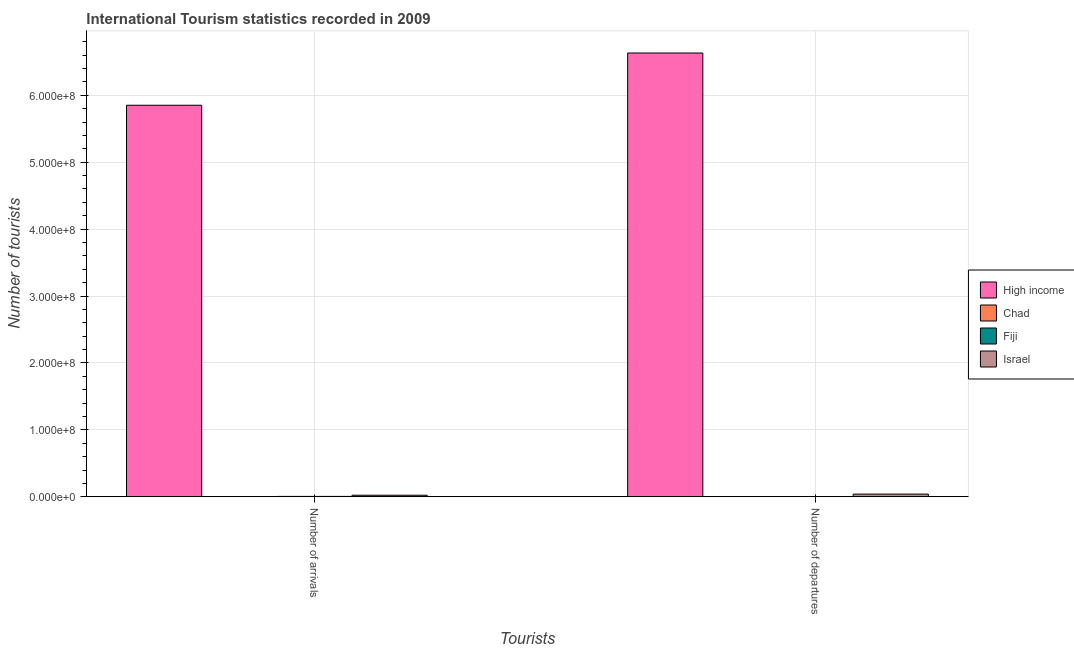How many different coloured bars are there?
Make the answer very short. 4. Are the number of bars per tick equal to the number of legend labels?
Keep it short and to the point. Yes. Are the number of bars on each tick of the X-axis equal?
Ensure brevity in your answer.  Yes. How many bars are there on the 2nd tick from the left?
Your answer should be compact. 4. How many bars are there on the 2nd tick from the right?
Give a very brief answer. 4. What is the label of the 1st group of bars from the left?
Provide a succinct answer. Number of arrivals. What is the number of tourist arrivals in Chad?
Provide a short and direct response. 7.00e+04. Across all countries, what is the maximum number of tourist departures?
Keep it short and to the point. 6.63e+08. In which country was the number of tourist departures minimum?
Make the answer very short. Chad. What is the total number of tourist arrivals in the graph?
Make the answer very short. 5.88e+08. What is the difference between the number of tourist departures in High income and that in Chad?
Your answer should be very brief. 6.63e+08. What is the difference between the number of tourist arrivals in Chad and the number of tourist departures in Fiji?
Ensure brevity in your answer.  -5.50e+04. What is the average number of tourist departures per country?
Offer a very short reply. 1.67e+08. What is the difference between the number of tourist arrivals and number of tourist departures in Chad?
Make the answer very short. 4000. What is the ratio of the number of tourist arrivals in High income to that in Fiji?
Offer a very short reply. 1079.57. What does the 2nd bar from the left in Number of departures represents?
Make the answer very short. Chad. What does the 3rd bar from the right in Number of departures represents?
Keep it short and to the point. Chad. How many bars are there?
Ensure brevity in your answer.  8. Are all the bars in the graph horizontal?
Ensure brevity in your answer.  No. How many countries are there in the graph?
Keep it short and to the point. 4. Are the values on the major ticks of Y-axis written in scientific E-notation?
Provide a succinct answer. Yes. Does the graph contain grids?
Offer a terse response. Yes. How many legend labels are there?
Keep it short and to the point. 4. What is the title of the graph?
Your answer should be very brief. International Tourism statistics recorded in 2009. What is the label or title of the X-axis?
Ensure brevity in your answer.  Tourists. What is the label or title of the Y-axis?
Your answer should be very brief. Number of tourists. What is the Number of tourists of High income in Number of arrivals?
Give a very brief answer. 5.85e+08. What is the Number of tourists of Fiji in Number of arrivals?
Offer a terse response. 5.42e+05. What is the Number of tourists in Israel in Number of arrivals?
Offer a terse response. 2.32e+06. What is the Number of tourists in High income in Number of departures?
Ensure brevity in your answer.  6.63e+08. What is the Number of tourists in Chad in Number of departures?
Offer a very short reply. 6.60e+04. What is the Number of tourists of Fiji in Number of departures?
Give a very brief answer. 1.25e+05. What is the Number of tourists in Israel in Number of departures?
Make the answer very short. 4.01e+06. Across all Tourists, what is the maximum Number of tourists in High income?
Give a very brief answer. 6.63e+08. Across all Tourists, what is the maximum Number of tourists in Fiji?
Ensure brevity in your answer.  5.42e+05. Across all Tourists, what is the maximum Number of tourists in Israel?
Provide a short and direct response. 4.01e+06. Across all Tourists, what is the minimum Number of tourists of High income?
Provide a short and direct response. 5.85e+08. Across all Tourists, what is the minimum Number of tourists of Chad?
Offer a terse response. 6.60e+04. Across all Tourists, what is the minimum Number of tourists of Fiji?
Make the answer very short. 1.25e+05. Across all Tourists, what is the minimum Number of tourists in Israel?
Offer a terse response. 2.32e+06. What is the total Number of tourists of High income in the graph?
Your answer should be compact. 1.25e+09. What is the total Number of tourists of Chad in the graph?
Offer a very short reply. 1.36e+05. What is the total Number of tourists in Fiji in the graph?
Offer a terse response. 6.67e+05. What is the total Number of tourists of Israel in the graph?
Provide a short and direct response. 6.33e+06. What is the difference between the Number of tourists in High income in Number of arrivals and that in Number of departures?
Provide a succinct answer. -7.80e+07. What is the difference between the Number of tourists in Chad in Number of arrivals and that in Number of departures?
Give a very brief answer. 4000. What is the difference between the Number of tourists in Fiji in Number of arrivals and that in Number of departures?
Your answer should be very brief. 4.17e+05. What is the difference between the Number of tourists in Israel in Number of arrivals and that in Number of departures?
Provide a succinct answer. -1.69e+06. What is the difference between the Number of tourists in High income in Number of arrivals and the Number of tourists in Chad in Number of departures?
Ensure brevity in your answer.  5.85e+08. What is the difference between the Number of tourists of High income in Number of arrivals and the Number of tourists of Fiji in Number of departures?
Ensure brevity in your answer.  5.85e+08. What is the difference between the Number of tourists of High income in Number of arrivals and the Number of tourists of Israel in Number of departures?
Your answer should be compact. 5.81e+08. What is the difference between the Number of tourists of Chad in Number of arrivals and the Number of tourists of Fiji in Number of departures?
Offer a terse response. -5.50e+04. What is the difference between the Number of tourists in Chad in Number of arrivals and the Number of tourists in Israel in Number of departures?
Your answer should be very brief. -3.94e+06. What is the difference between the Number of tourists in Fiji in Number of arrivals and the Number of tourists in Israel in Number of departures?
Give a very brief answer. -3.46e+06. What is the average Number of tourists of High income per Tourists?
Offer a terse response. 6.24e+08. What is the average Number of tourists of Chad per Tourists?
Keep it short and to the point. 6.80e+04. What is the average Number of tourists of Fiji per Tourists?
Keep it short and to the point. 3.34e+05. What is the average Number of tourists of Israel per Tourists?
Keep it short and to the point. 3.16e+06. What is the difference between the Number of tourists in High income and Number of tourists in Chad in Number of arrivals?
Your answer should be compact. 5.85e+08. What is the difference between the Number of tourists of High income and Number of tourists of Fiji in Number of arrivals?
Give a very brief answer. 5.85e+08. What is the difference between the Number of tourists of High income and Number of tourists of Israel in Number of arrivals?
Provide a short and direct response. 5.83e+08. What is the difference between the Number of tourists in Chad and Number of tourists in Fiji in Number of arrivals?
Provide a short and direct response. -4.72e+05. What is the difference between the Number of tourists in Chad and Number of tourists in Israel in Number of arrivals?
Keep it short and to the point. -2.25e+06. What is the difference between the Number of tourists of Fiji and Number of tourists of Israel in Number of arrivals?
Ensure brevity in your answer.  -1.78e+06. What is the difference between the Number of tourists in High income and Number of tourists in Chad in Number of departures?
Ensure brevity in your answer.  6.63e+08. What is the difference between the Number of tourists in High income and Number of tourists in Fiji in Number of departures?
Offer a very short reply. 6.63e+08. What is the difference between the Number of tourists of High income and Number of tourists of Israel in Number of departures?
Your answer should be very brief. 6.59e+08. What is the difference between the Number of tourists in Chad and Number of tourists in Fiji in Number of departures?
Provide a succinct answer. -5.90e+04. What is the difference between the Number of tourists of Chad and Number of tourists of Israel in Number of departures?
Provide a succinct answer. -3.94e+06. What is the difference between the Number of tourists in Fiji and Number of tourists in Israel in Number of departures?
Your answer should be very brief. -3.88e+06. What is the ratio of the Number of tourists of High income in Number of arrivals to that in Number of departures?
Keep it short and to the point. 0.88. What is the ratio of the Number of tourists in Chad in Number of arrivals to that in Number of departures?
Your answer should be compact. 1.06. What is the ratio of the Number of tourists of Fiji in Number of arrivals to that in Number of departures?
Offer a terse response. 4.34. What is the ratio of the Number of tourists in Israel in Number of arrivals to that in Number of departures?
Your response must be concise. 0.58. What is the difference between the highest and the second highest Number of tourists of High income?
Make the answer very short. 7.80e+07. What is the difference between the highest and the second highest Number of tourists in Chad?
Provide a succinct answer. 4000. What is the difference between the highest and the second highest Number of tourists in Fiji?
Your answer should be compact. 4.17e+05. What is the difference between the highest and the second highest Number of tourists in Israel?
Your response must be concise. 1.69e+06. What is the difference between the highest and the lowest Number of tourists of High income?
Offer a terse response. 7.80e+07. What is the difference between the highest and the lowest Number of tourists in Chad?
Offer a very short reply. 4000. What is the difference between the highest and the lowest Number of tourists of Fiji?
Ensure brevity in your answer.  4.17e+05. What is the difference between the highest and the lowest Number of tourists of Israel?
Ensure brevity in your answer.  1.69e+06. 